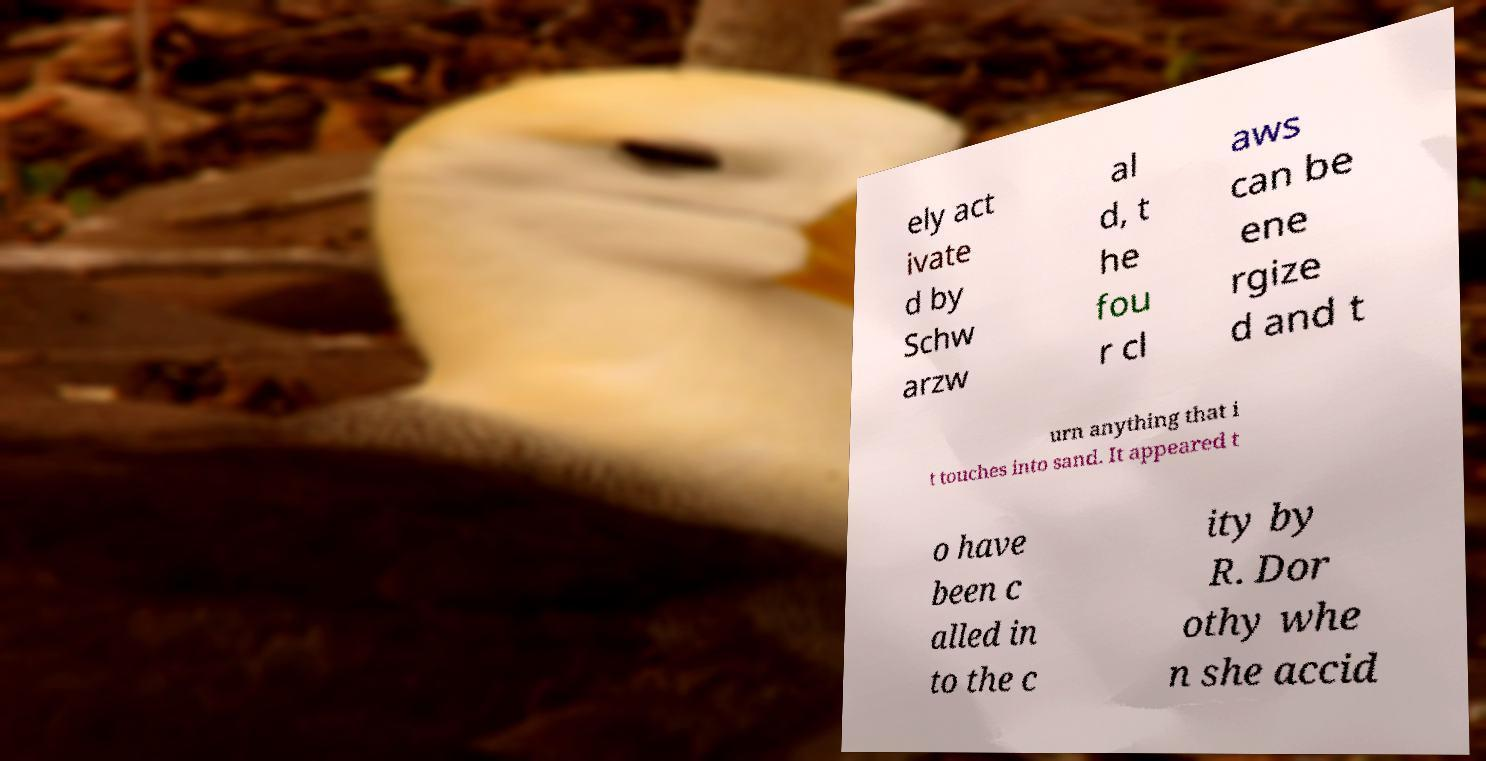Please identify and transcribe the text found in this image. ely act ivate d by Schw arzw al d, t he fou r cl aws can be ene rgize d and t urn anything that i t touches into sand. It appeared t o have been c alled in to the c ity by R. Dor othy whe n she accid 